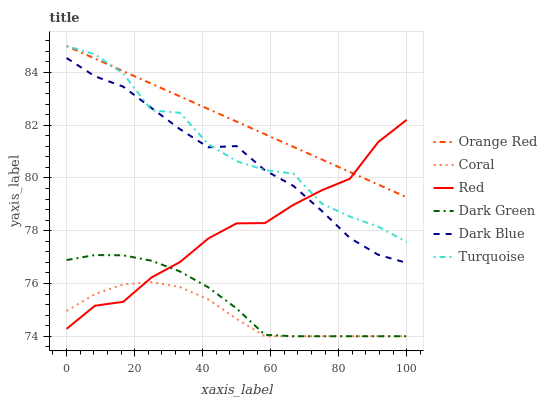Does Coral have the minimum area under the curve?
Answer yes or no. Yes. Does Orange Red have the maximum area under the curve?
Answer yes or no. Yes. Does Dark Blue have the minimum area under the curve?
Answer yes or no. No. Does Dark Blue have the maximum area under the curve?
Answer yes or no. No. Is Orange Red the smoothest?
Answer yes or no. Yes. Is Turquoise the roughest?
Answer yes or no. Yes. Is Coral the smoothest?
Answer yes or no. No. Is Coral the roughest?
Answer yes or no. No. Does Coral have the lowest value?
Answer yes or no. Yes. Does Dark Blue have the lowest value?
Answer yes or no. No. Does Orange Red have the highest value?
Answer yes or no. Yes. Does Dark Blue have the highest value?
Answer yes or no. No. Is Dark Green less than Orange Red?
Answer yes or no. Yes. Is Orange Red greater than Dark Green?
Answer yes or no. Yes. Does Dark Blue intersect Turquoise?
Answer yes or no. Yes. Is Dark Blue less than Turquoise?
Answer yes or no. No. Is Dark Blue greater than Turquoise?
Answer yes or no. No. Does Dark Green intersect Orange Red?
Answer yes or no. No. 